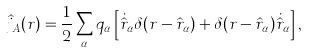Convert formula to latex. <formula><loc_0><loc_0><loc_500><loc_500>\hat { j } _ { A } ( r ) = { \frac { 1 } { 2 } } \sum _ { \alpha } q _ { \alpha } \left [ \dot { \hat { r } } _ { \alpha } \delta ( r - \hat { r } _ { \alpha } ) + \delta ( r - \hat { r } _ { \alpha } ) \dot { \hat { r } } _ { \alpha } \right ] ,</formula> 